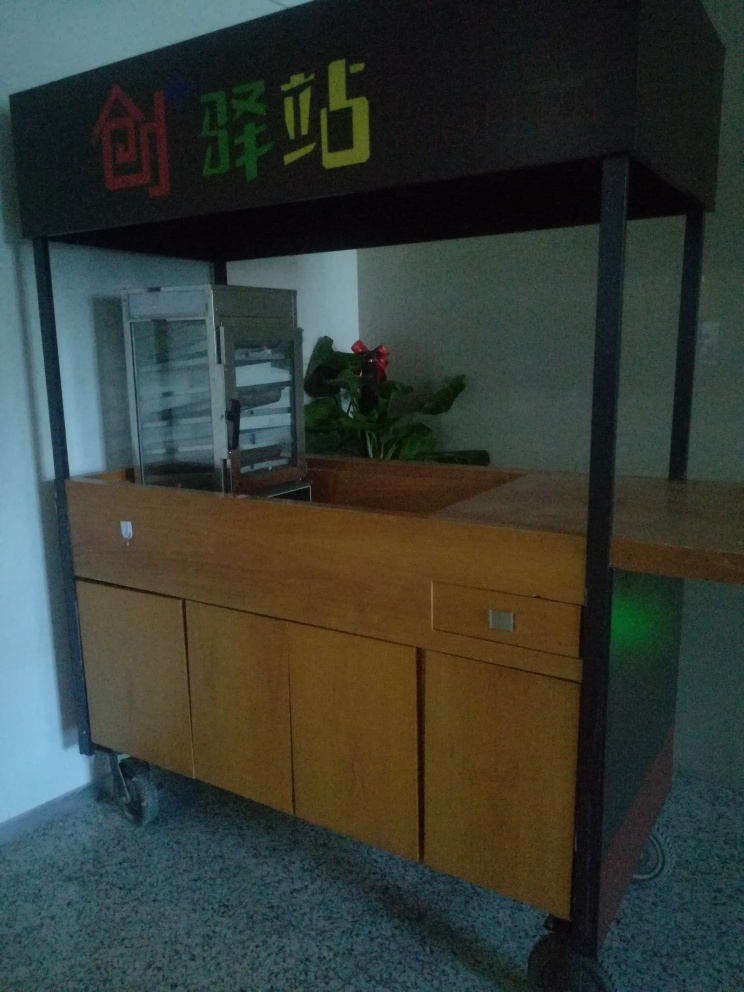Can you describe the color scheme of the sign above the counter? The sign above the counter features a tri-color scheme with red, green, and what appears to be either a very dark green or black. These colors are quite bold and stand out against the muted colors of the rest of the scene. 